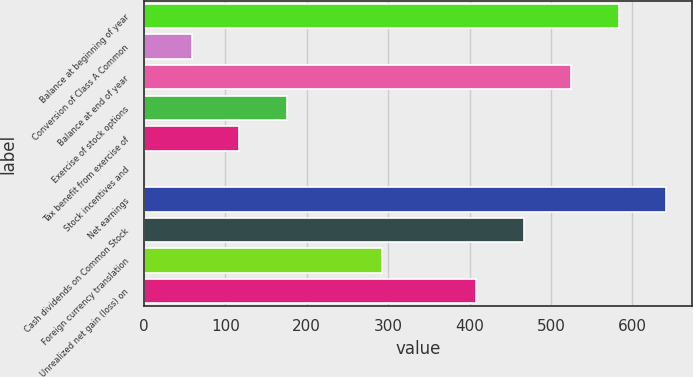<chart> <loc_0><loc_0><loc_500><loc_500><bar_chart><fcel>Balance at beginning of year<fcel>Conversion of Class A Common<fcel>Balance at end of year<fcel>Exercise of stock options<fcel>Tax benefit from exercise of<fcel>Stock incentives and<fcel>Net earnings<fcel>Cash dividends on Common Stock<fcel>Foreign currency translation<fcel>Unrealized net gain (loss) on<nl><fcel>583.5<fcel>58.53<fcel>525.17<fcel>175.19<fcel>116.86<fcel>0.2<fcel>641.83<fcel>466.84<fcel>291.85<fcel>408.51<nl></chart> 